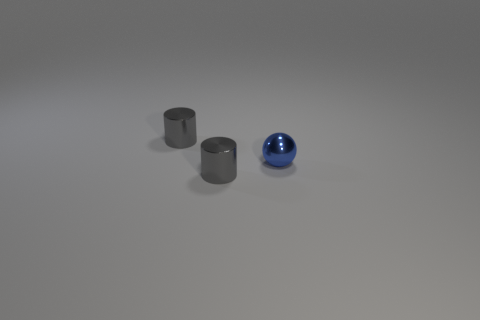The tiny blue shiny thing on the right side of the tiny cylinder that is right of the cylinder behind the tiny blue object is what shape?
Your response must be concise. Sphere. How many objects are either purple matte cubes or small objects left of the small blue thing?
Your response must be concise. 2. There is a gray metal cylinder that is in front of the blue thing; is it the same size as the blue ball?
Provide a short and direct response. Yes. There is a object that is in front of the tiny blue object; what is its material?
Offer a terse response. Metal. Are there any other things that have the same color as the ball?
Keep it short and to the point. No. How many matte things are either small cylinders or small blue objects?
Offer a terse response. 0. Are there more tiny metallic balls to the right of the small blue thing than small spheres?
Your answer should be very brief. No. How many other objects are there of the same material as the sphere?
Your answer should be very brief. 2. What number of tiny objects are either shiny spheres or gray things?
Your answer should be compact. 3. There is a metallic cylinder that is in front of the metallic sphere; how many metal cylinders are on the left side of it?
Offer a terse response. 1. 